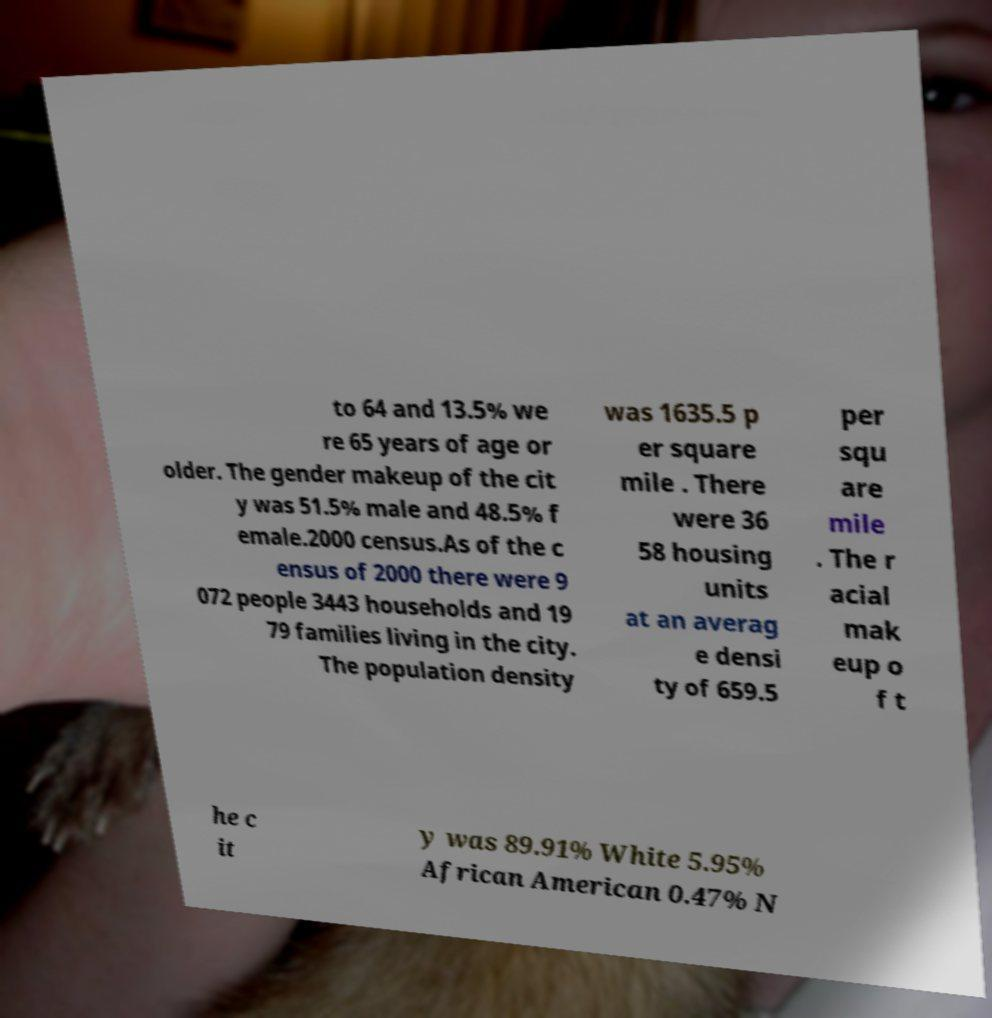Can you read and provide the text displayed in the image?This photo seems to have some interesting text. Can you extract and type it out for me? to 64 and 13.5% we re 65 years of age or older. The gender makeup of the cit y was 51.5% male and 48.5% f emale.2000 census.As of the c ensus of 2000 there were 9 072 people 3443 households and 19 79 families living in the city. The population density was 1635.5 p er square mile . There were 36 58 housing units at an averag e densi ty of 659.5 per squ are mile . The r acial mak eup o f t he c it y was 89.91% White 5.95% African American 0.47% N 